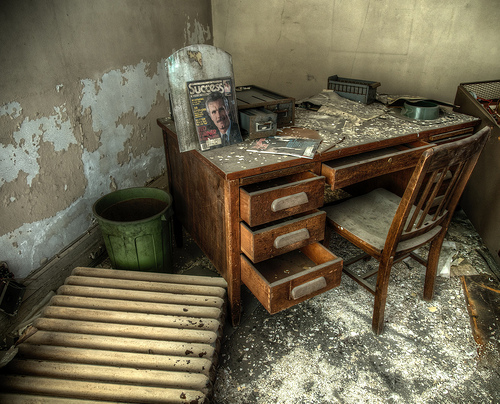<image>
Can you confirm if the pallet is next to the trashcan? Yes. The pallet is positioned adjacent to the trashcan, located nearby in the same general area. 